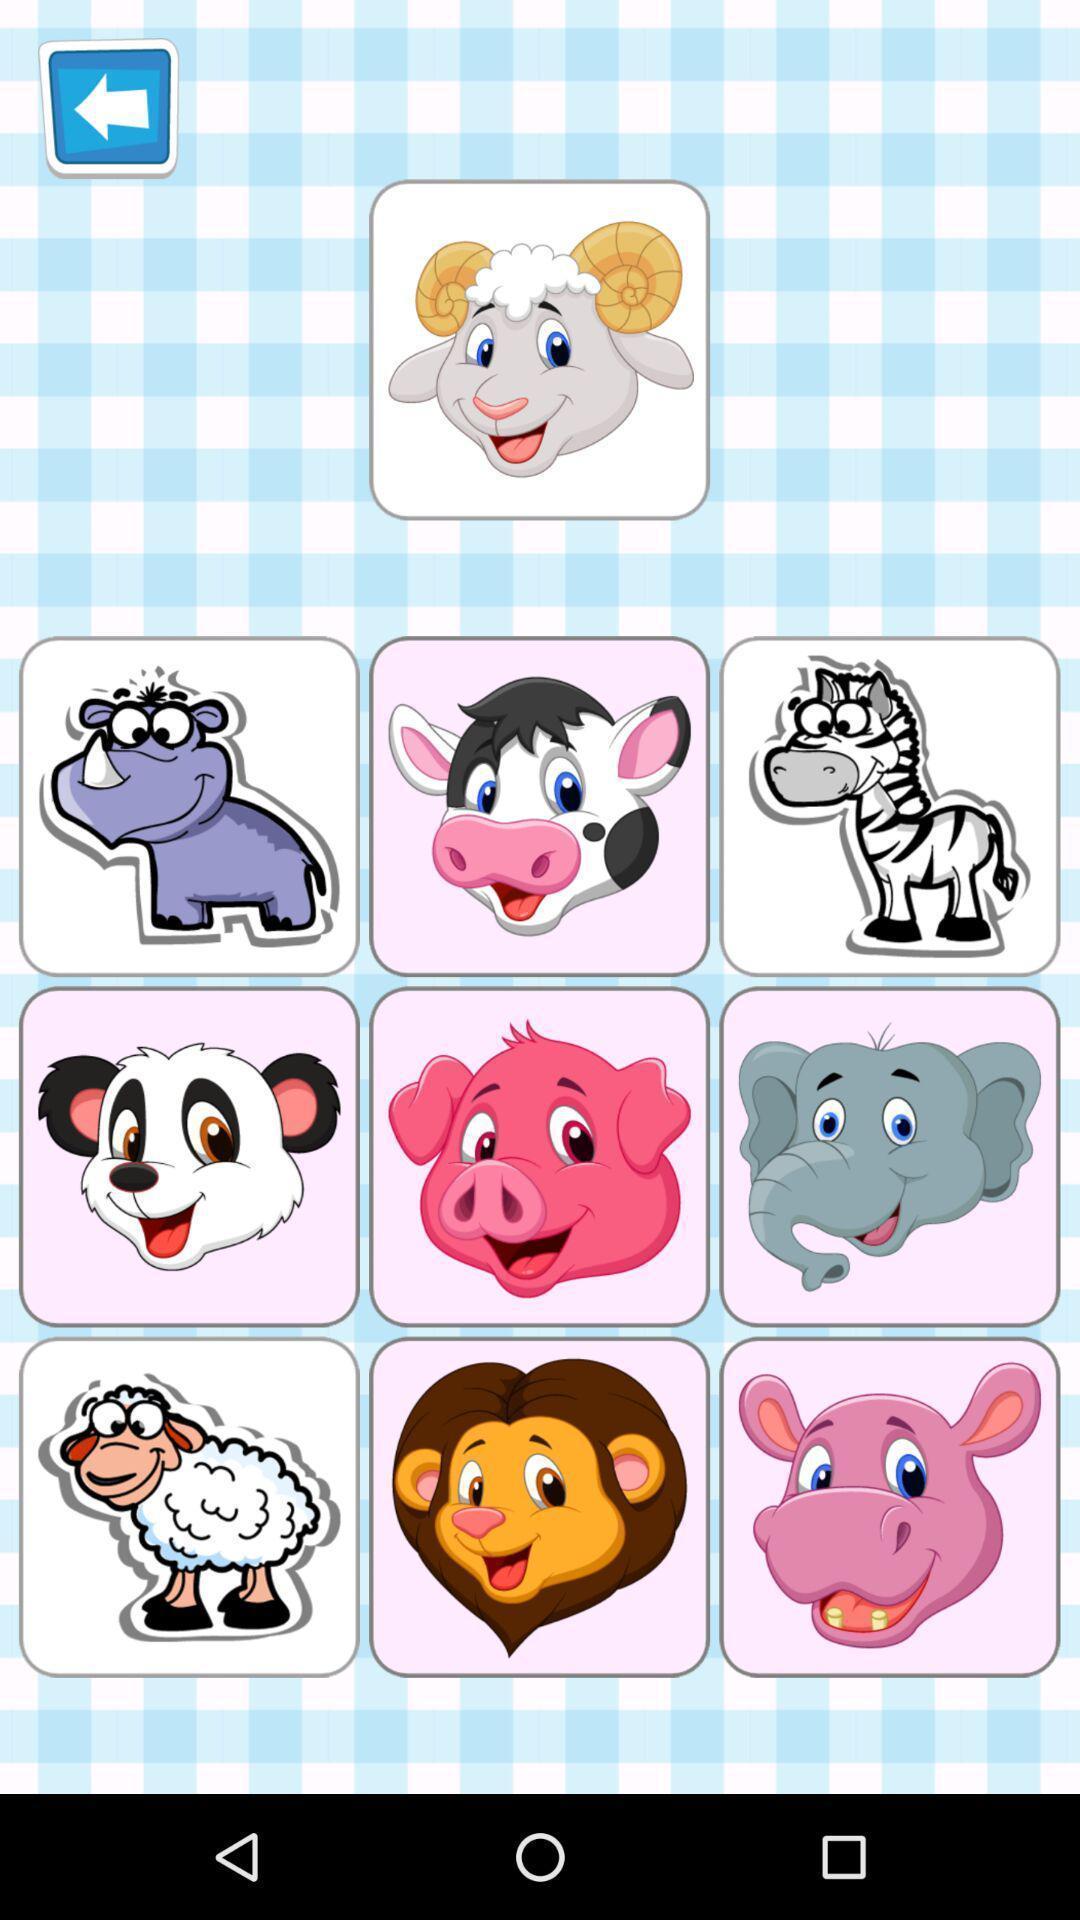Summarize the main components in this picture. Screen displaying different types of animal images. 